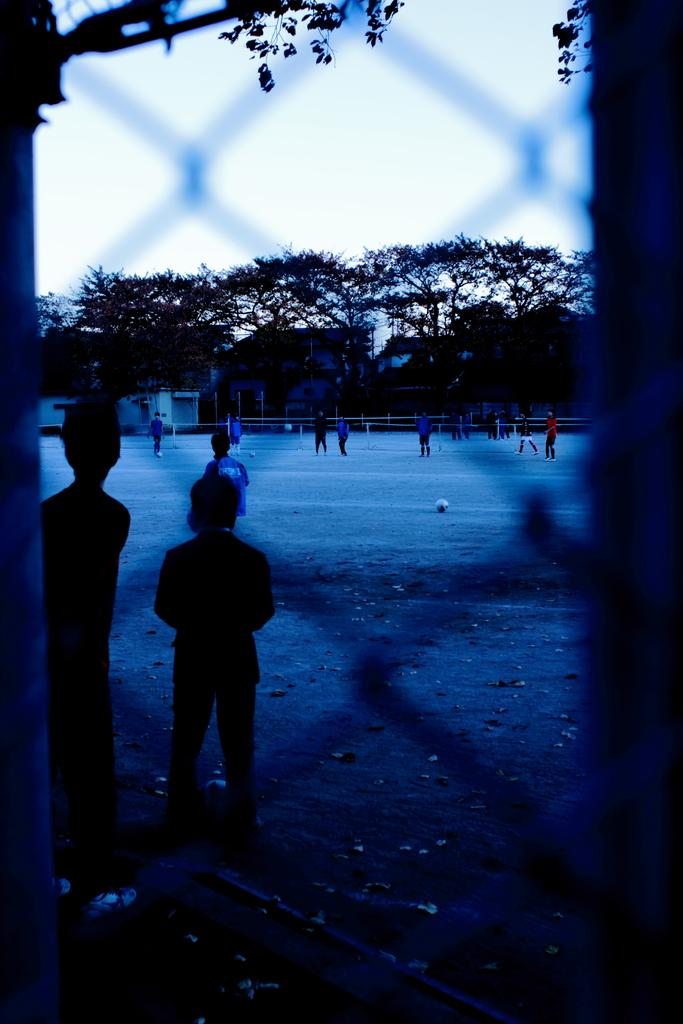What are the people in the image doing? The people in the image are standing on the ground. What can be seen through the fence in the image? A: There are balls visible through the fence in the image. What is visible in the background of the image? There are buildings, trees, and the sky visible in the background of the image. What type of discussion is taking place between the snakes in the image? There are no snakes present in the image, so there cannot be a discussion between them. 